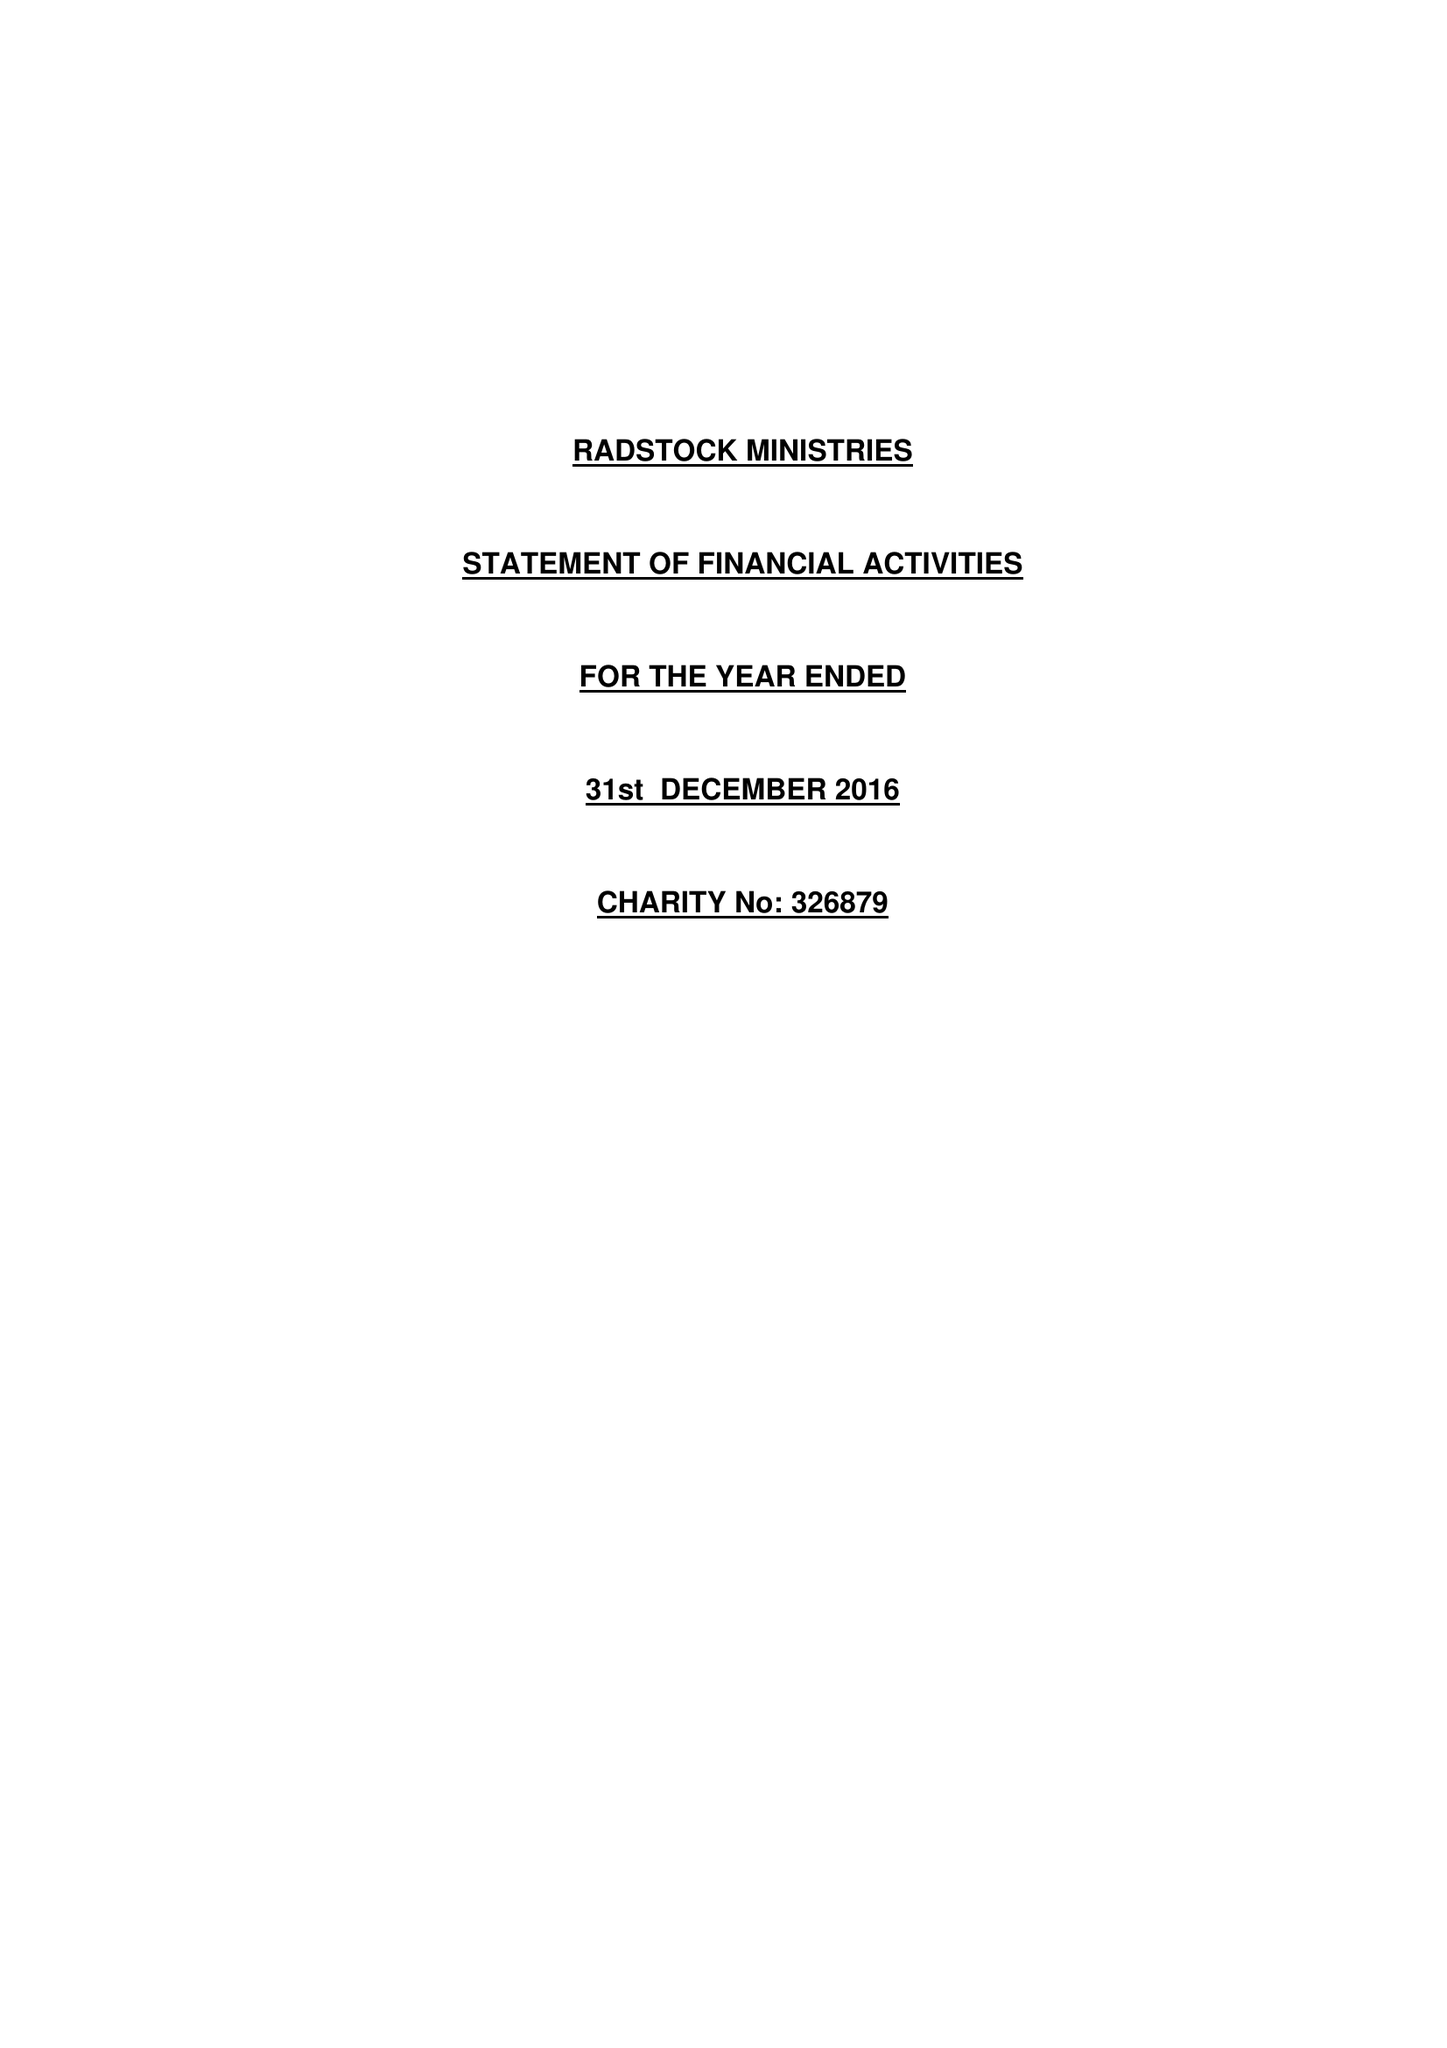What is the value for the address__postcode?
Answer the question using a single word or phrase. LU2 7XP 